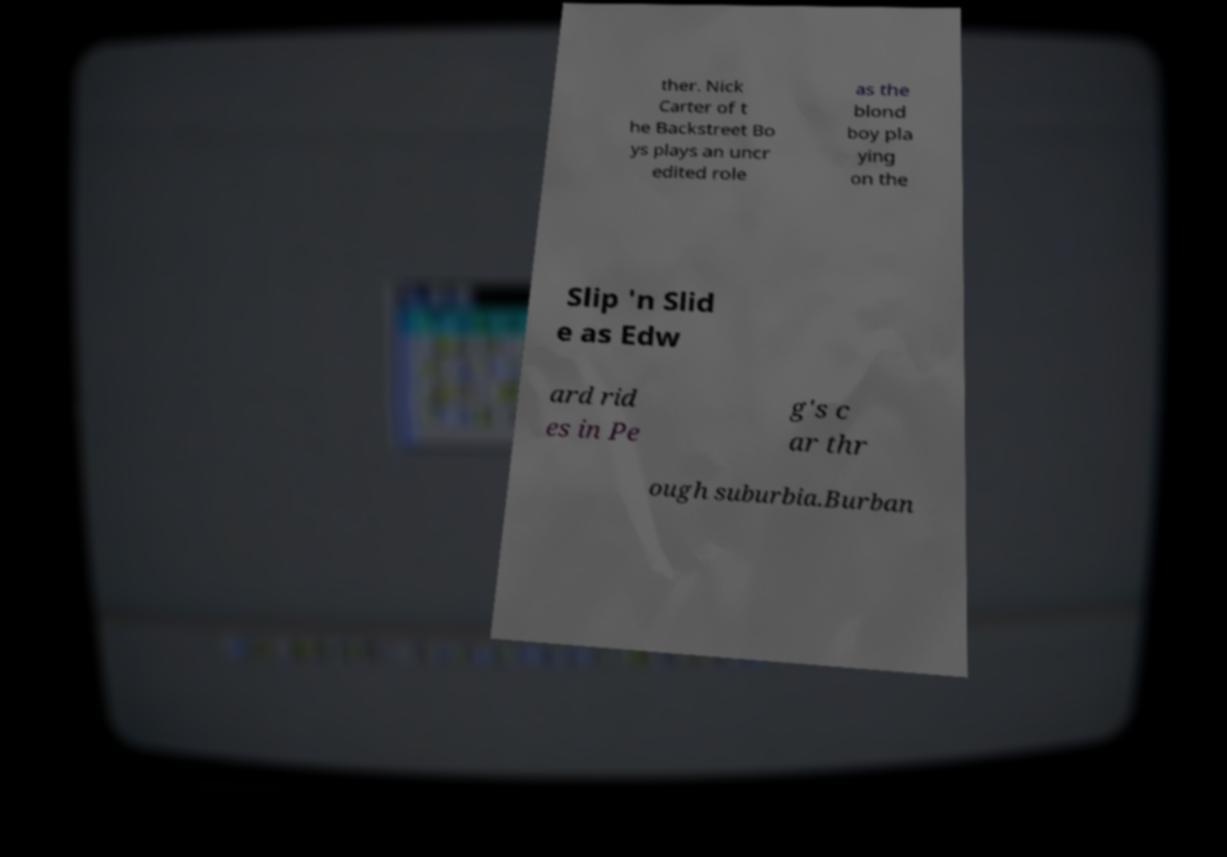Please identify and transcribe the text found in this image. ther. Nick Carter of t he Backstreet Bo ys plays an uncr edited role as the blond boy pla ying on the Slip 'n Slid e as Edw ard rid es in Pe g's c ar thr ough suburbia.Burban 